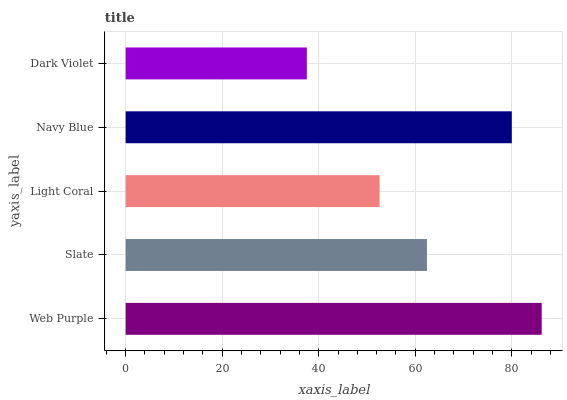Is Dark Violet the minimum?
Answer yes or no. Yes. Is Web Purple the maximum?
Answer yes or no. Yes. Is Slate the minimum?
Answer yes or no. No. Is Slate the maximum?
Answer yes or no. No. Is Web Purple greater than Slate?
Answer yes or no. Yes. Is Slate less than Web Purple?
Answer yes or no. Yes. Is Slate greater than Web Purple?
Answer yes or no. No. Is Web Purple less than Slate?
Answer yes or no. No. Is Slate the high median?
Answer yes or no. Yes. Is Slate the low median?
Answer yes or no. Yes. Is Web Purple the high median?
Answer yes or no. No. Is Light Coral the low median?
Answer yes or no. No. 